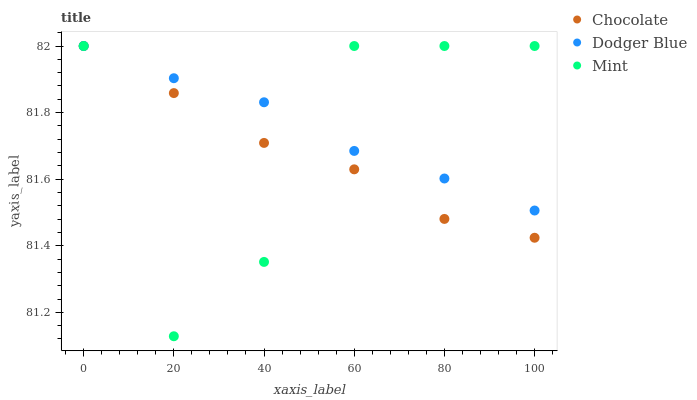Does Chocolate have the minimum area under the curve?
Answer yes or no. Yes. Does Dodger Blue have the maximum area under the curve?
Answer yes or no. Yes. Does Dodger Blue have the minimum area under the curve?
Answer yes or no. No. Does Chocolate have the maximum area under the curve?
Answer yes or no. No. Is Dodger Blue the smoothest?
Answer yes or no. Yes. Is Mint the roughest?
Answer yes or no. Yes. Is Chocolate the smoothest?
Answer yes or no. No. Is Chocolate the roughest?
Answer yes or no. No. Does Mint have the lowest value?
Answer yes or no. Yes. Does Chocolate have the lowest value?
Answer yes or no. No. Does Chocolate have the highest value?
Answer yes or no. Yes. Does Chocolate intersect Dodger Blue?
Answer yes or no. Yes. Is Chocolate less than Dodger Blue?
Answer yes or no. No. Is Chocolate greater than Dodger Blue?
Answer yes or no. No. 